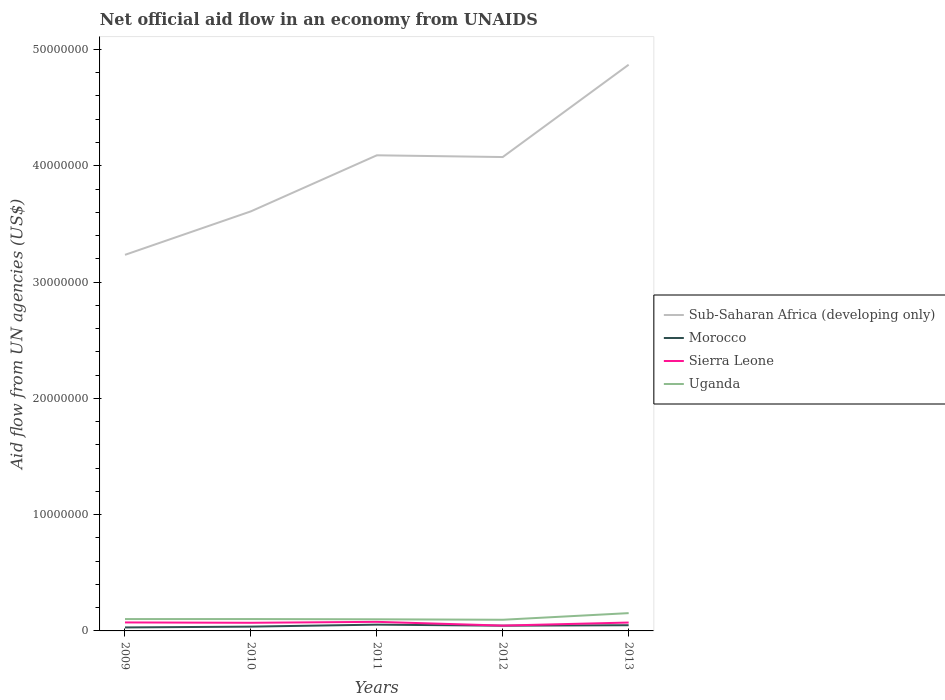How many different coloured lines are there?
Offer a very short reply. 4. Does the line corresponding to Uganda intersect with the line corresponding to Morocco?
Your answer should be very brief. No. Across all years, what is the maximum net official aid flow in Morocco?
Your answer should be very brief. 3.00e+05. What is the total net official aid flow in Morocco in the graph?
Give a very brief answer. -1.70e+05. What is the difference between the highest and the second highest net official aid flow in Uganda?
Keep it short and to the point. 5.70e+05. What is the difference between the highest and the lowest net official aid flow in Uganda?
Make the answer very short. 1. How many lines are there?
Your answer should be very brief. 4. What is the difference between two consecutive major ticks on the Y-axis?
Offer a terse response. 1.00e+07. Are the values on the major ticks of Y-axis written in scientific E-notation?
Make the answer very short. No. Does the graph contain any zero values?
Ensure brevity in your answer.  No. Where does the legend appear in the graph?
Make the answer very short. Center right. How many legend labels are there?
Ensure brevity in your answer.  4. How are the legend labels stacked?
Provide a short and direct response. Vertical. What is the title of the graph?
Make the answer very short. Net official aid flow in an economy from UNAIDS. Does "Trinidad and Tobago" appear as one of the legend labels in the graph?
Ensure brevity in your answer.  No. What is the label or title of the X-axis?
Give a very brief answer. Years. What is the label or title of the Y-axis?
Your response must be concise. Aid flow from UN agencies (US$). What is the Aid flow from UN agencies (US$) of Sub-Saharan Africa (developing only) in 2009?
Provide a short and direct response. 3.23e+07. What is the Aid flow from UN agencies (US$) in Sierra Leone in 2009?
Your response must be concise. 7.30e+05. What is the Aid flow from UN agencies (US$) in Uganda in 2009?
Provide a short and direct response. 1.02e+06. What is the Aid flow from UN agencies (US$) in Sub-Saharan Africa (developing only) in 2010?
Your answer should be compact. 3.61e+07. What is the Aid flow from UN agencies (US$) in Sierra Leone in 2010?
Make the answer very short. 7.00e+05. What is the Aid flow from UN agencies (US$) of Uganda in 2010?
Provide a short and direct response. 1.02e+06. What is the Aid flow from UN agencies (US$) in Sub-Saharan Africa (developing only) in 2011?
Provide a succinct answer. 4.09e+07. What is the Aid flow from UN agencies (US$) in Morocco in 2011?
Your answer should be compact. 5.40e+05. What is the Aid flow from UN agencies (US$) of Sierra Leone in 2011?
Provide a short and direct response. 7.80e+05. What is the Aid flow from UN agencies (US$) in Sub-Saharan Africa (developing only) in 2012?
Provide a succinct answer. 4.08e+07. What is the Aid flow from UN agencies (US$) of Morocco in 2012?
Your answer should be very brief. 4.50e+05. What is the Aid flow from UN agencies (US$) in Uganda in 2012?
Keep it short and to the point. 9.60e+05. What is the Aid flow from UN agencies (US$) in Sub-Saharan Africa (developing only) in 2013?
Ensure brevity in your answer.  4.87e+07. What is the Aid flow from UN agencies (US$) of Sierra Leone in 2013?
Provide a short and direct response. 7.20e+05. What is the Aid flow from UN agencies (US$) in Uganda in 2013?
Your answer should be very brief. 1.53e+06. Across all years, what is the maximum Aid flow from UN agencies (US$) in Sub-Saharan Africa (developing only)?
Make the answer very short. 4.87e+07. Across all years, what is the maximum Aid flow from UN agencies (US$) in Morocco?
Keep it short and to the point. 5.40e+05. Across all years, what is the maximum Aid flow from UN agencies (US$) in Sierra Leone?
Make the answer very short. 7.80e+05. Across all years, what is the maximum Aid flow from UN agencies (US$) in Uganda?
Offer a very short reply. 1.53e+06. Across all years, what is the minimum Aid flow from UN agencies (US$) in Sub-Saharan Africa (developing only)?
Keep it short and to the point. 3.23e+07. Across all years, what is the minimum Aid flow from UN agencies (US$) of Morocco?
Your response must be concise. 3.00e+05. Across all years, what is the minimum Aid flow from UN agencies (US$) of Uganda?
Ensure brevity in your answer.  9.60e+05. What is the total Aid flow from UN agencies (US$) of Sub-Saharan Africa (developing only) in the graph?
Keep it short and to the point. 1.99e+08. What is the total Aid flow from UN agencies (US$) in Morocco in the graph?
Offer a terse response. 2.15e+06. What is the total Aid flow from UN agencies (US$) in Sierra Leone in the graph?
Keep it short and to the point. 3.39e+06. What is the total Aid flow from UN agencies (US$) of Uganda in the graph?
Your response must be concise. 5.53e+06. What is the difference between the Aid flow from UN agencies (US$) in Sub-Saharan Africa (developing only) in 2009 and that in 2010?
Make the answer very short. -3.74e+06. What is the difference between the Aid flow from UN agencies (US$) of Sub-Saharan Africa (developing only) in 2009 and that in 2011?
Your answer should be very brief. -8.56e+06. What is the difference between the Aid flow from UN agencies (US$) of Morocco in 2009 and that in 2011?
Keep it short and to the point. -2.40e+05. What is the difference between the Aid flow from UN agencies (US$) in Sierra Leone in 2009 and that in 2011?
Make the answer very short. -5.00e+04. What is the difference between the Aid flow from UN agencies (US$) in Sub-Saharan Africa (developing only) in 2009 and that in 2012?
Offer a terse response. -8.41e+06. What is the difference between the Aid flow from UN agencies (US$) in Sierra Leone in 2009 and that in 2012?
Offer a very short reply. 2.70e+05. What is the difference between the Aid flow from UN agencies (US$) in Uganda in 2009 and that in 2012?
Ensure brevity in your answer.  6.00e+04. What is the difference between the Aid flow from UN agencies (US$) in Sub-Saharan Africa (developing only) in 2009 and that in 2013?
Offer a terse response. -1.64e+07. What is the difference between the Aid flow from UN agencies (US$) in Morocco in 2009 and that in 2013?
Keep it short and to the point. -1.90e+05. What is the difference between the Aid flow from UN agencies (US$) in Uganda in 2009 and that in 2013?
Make the answer very short. -5.10e+05. What is the difference between the Aid flow from UN agencies (US$) in Sub-Saharan Africa (developing only) in 2010 and that in 2011?
Your answer should be compact. -4.82e+06. What is the difference between the Aid flow from UN agencies (US$) in Morocco in 2010 and that in 2011?
Give a very brief answer. -1.70e+05. What is the difference between the Aid flow from UN agencies (US$) in Sierra Leone in 2010 and that in 2011?
Your response must be concise. -8.00e+04. What is the difference between the Aid flow from UN agencies (US$) of Sub-Saharan Africa (developing only) in 2010 and that in 2012?
Ensure brevity in your answer.  -4.67e+06. What is the difference between the Aid flow from UN agencies (US$) of Sierra Leone in 2010 and that in 2012?
Offer a terse response. 2.40e+05. What is the difference between the Aid flow from UN agencies (US$) of Uganda in 2010 and that in 2012?
Make the answer very short. 6.00e+04. What is the difference between the Aid flow from UN agencies (US$) in Sub-Saharan Africa (developing only) in 2010 and that in 2013?
Offer a terse response. -1.26e+07. What is the difference between the Aid flow from UN agencies (US$) in Morocco in 2010 and that in 2013?
Provide a succinct answer. -1.20e+05. What is the difference between the Aid flow from UN agencies (US$) of Uganda in 2010 and that in 2013?
Offer a terse response. -5.10e+05. What is the difference between the Aid flow from UN agencies (US$) of Sub-Saharan Africa (developing only) in 2011 and that in 2012?
Provide a short and direct response. 1.50e+05. What is the difference between the Aid flow from UN agencies (US$) of Sub-Saharan Africa (developing only) in 2011 and that in 2013?
Give a very brief answer. -7.79e+06. What is the difference between the Aid flow from UN agencies (US$) of Sierra Leone in 2011 and that in 2013?
Keep it short and to the point. 6.00e+04. What is the difference between the Aid flow from UN agencies (US$) of Uganda in 2011 and that in 2013?
Provide a succinct answer. -5.30e+05. What is the difference between the Aid flow from UN agencies (US$) of Sub-Saharan Africa (developing only) in 2012 and that in 2013?
Give a very brief answer. -7.94e+06. What is the difference between the Aid flow from UN agencies (US$) in Morocco in 2012 and that in 2013?
Provide a short and direct response. -4.00e+04. What is the difference between the Aid flow from UN agencies (US$) in Sierra Leone in 2012 and that in 2013?
Your answer should be very brief. -2.60e+05. What is the difference between the Aid flow from UN agencies (US$) in Uganda in 2012 and that in 2013?
Provide a succinct answer. -5.70e+05. What is the difference between the Aid flow from UN agencies (US$) of Sub-Saharan Africa (developing only) in 2009 and the Aid flow from UN agencies (US$) of Morocco in 2010?
Your response must be concise. 3.20e+07. What is the difference between the Aid flow from UN agencies (US$) in Sub-Saharan Africa (developing only) in 2009 and the Aid flow from UN agencies (US$) in Sierra Leone in 2010?
Provide a succinct answer. 3.16e+07. What is the difference between the Aid flow from UN agencies (US$) in Sub-Saharan Africa (developing only) in 2009 and the Aid flow from UN agencies (US$) in Uganda in 2010?
Offer a terse response. 3.13e+07. What is the difference between the Aid flow from UN agencies (US$) of Morocco in 2009 and the Aid flow from UN agencies (US$) of Sierra Leone in 2010?
Offer a very short reply. -4.00e+05. What is the difference between the Aid flow from UN agencies (US$) in Morocco in 2009 and the Aid flow from UN agencies (US$) in Uganda in 2010?
Make the answer very short. -7.20e+05. What is the difference between the Aid flow from UN agencies (US$) in Sub-Saharan Africa (developing only) in 2009 and the Aid flow from UN agencies (US$) in Morocco in 2011?
Your response must be concise. 3.18e+07. What is the difference between the Aid flow from UN agencies (US$) of Sub-Saharan Africa (developing only) in 2009 and the Aid flow from UN agencies (US$) of Sierra Leone in 2011?
Provide a succinct answer. 3.16e+07. What is the difference between the Aid flow from UN agencies (US$) of Sub-Saharan Africa (developing only) in 2009 and the Aid flow from UN agencies (US$) of Uganda in 2011?
Keep it short and to the point. 3.13e+07. What is the difference between the Aid flow from UN agencies (US$) in Morocco in 2009 and the Aid flow from UN agencies (US$) in Sierra Leone in 2011?
Ensure brevity in your answer.  -4.80e+05. What is the difference between the Aid flow from UN agencies (US$) of Morocco in 2009 and the Aid flow from UN agencies (US$) of Uganda in 2011?
Your response must be concise. -7.00e+05. What is the difference between the Aid flow from UN agencies (US$) of Sierra Leone in 2009 and the Aid flow from UN agencies (US$) of Uganda in 2011?
Keep it short and to the point. -2.70e+05. What is the difference between the Aid flow from UN agencies (US$) of Sub-Saharan Africa (developing only) in 2009 and the Aid flow from UN agencies (US$) of Morocco in 2012?
Give a very brief answer. 3.19e+07. What is the difference between the Aid flow from UN agencies (US$) of Sub-Saharan Africa (developing only) in 2009 and the Aid flow from UN agencies (US$) of Sierra Leone in 2012?
Your answer should be compact. 3.19e+07. What is the difference between the Aid flow from UN agencies (US$) of Sub-Saharan Africa (developing only) in 2009 and the Aid flow from UN agencies (US$) of Uganda in 2012?
Ensure brevity in your answer.  3.14e+07. What is the difference between the Aid flow from UN agencies (US$) of Morocco in 2009 and the Aid flow from UN agencies (US$) of Uganda in 2012?
Keep it short and to the point. -6.60e+05. What is the difference between the Aid flow from UN agencies (US$) of Sub-Saharan Africa (developing only) in 2009 and the Aid flow from UN agencies (US$) of Morocco in 2013?
Your response must be concise. 3.18e+07. What is the difference between the Aid flow from UN agencies (US$) of Sub-Saharan Africa (developing only) in 2009 and the Aid flow from UN agencies (US$) of Sierra Leone in 2013?
Provide a short and direct response. 3.16e+07. What is the difference between the Aid flow from UN agencies (US$) in Sub-Saharan Africa (developing only) in 2009 and the Aid flow from UN agencies (US$) in Uganda in 2013?
Keep it short and to the point. 3.08e+07. What is the difference between the Aid flow from UN agencies (US$) of Morocco in 2009 and the Aid flow from UN agencies (US$) of Sierra Leone in 2013?
Ensure brevity in your answer.  -4.20e+05. What is the difference between the Aid flow from UN agencies (US$) in Morocco in 2009 and the Aid flow from UN agencies (US$) in Uganda in 2013?
Provide a succinct answer. -1.23e+06. What is the difference between the Aid flow from UN agencies (US$) of Sierra Leone in 2009 and the Aid flow from UN agencies (US$) of Uganda in 2013?
Ensure brevity in your answer.  -8.00e+05. What is the difference between the Aid flow from UN agencies (US$) of Sub-Saharan Africa (developing only) in 2010 and the Aid flow from UN agencies (US$) of Morocco in 2011?
Your answer should be very brief. 3.55e+07. What is the difference between the Aid flow from UN agencies (US$) in Sub-Saharan Africa (developing only) in 2010 and the Aid flow from UN agencies (US$) in Sierra Leone in 2011?
Your answer should be very brief. 3.53e+07. What is the difference between the Aid flow from UN agencies (US$) in Sub-Saharan Africa (developing only) in 2010 and the Aid flow from UN agencies (US$) in Uganda in 2011?
Your response must be concise. 3.51e+07. What is the difference between the Aid flow from UN agencies (US$) in Morocco in 2010 and the Aid flow from UN agencies (US$) in Sierra Leone in 2011?
Your response must be concise. -4.10e+05. What is the difference between the Aid flow from UN agencies (US$) in Morocco in 2010 and the Aid flow from UN agencies (US$) in Uganda in 2011?
Your answer should be very brief. -6.30e+05. What is the difference between the Aid flow from UN agencies (US$) in Sierra Leone in 2010 and the Aid flow from UN agencies (US$) in Uganda in 2011?
Offer a very short reply. -3.00e+05. What is the difference between the Aid flow from UN agencies (US$) of Sub-Saharan Africa (developing only) in 2010 and the Aid flow from UN agencies (US$) of Morocco in 2012?
Your response must be concise. 3.56e+07. What is the difference between the Aid flow from UN agencies (US$) of Sub-Saharan Africa (developing only) in 2010 and the Aid flow from UN agencies (US$) of Sierra Leone in 2012?
Ensure brevity in your answer.  3.56e+07. What is the difference between the Aid flow from UN agencies (US$) in Sub-Saharan Africa (developing only) in 2010 and the Aid flow from UN agencies (US$) in Uganda in 2012?
Make the answer very short. 3.51e+07. What is the difference between the Aid flow from UN agencies (US$) of Morocco in 2010 and the Aid flow from UN agencies (US$) of Uganda in 2012?
Offer a terse response. -5.90e+05. What is the difference between the Aid flow from UN agencies (US$) in Sub-Saharan Africa (developing only) in 2010 and the Aid flow from UN agencies (US$) in Morocco in 2013?
Give a very brief answer. 3.56e+07. What is the difference between the Aid flow from UN agencies (US$) in Sub-Saharan Africa (developing only) in 2010 and the Aid flow from UN agencies (US$) in Sierra Leone in 2013?
Offer a terse response. 3.54e+07. What is the difference between the Aid flow from UN agencies (US$) in Sub-Saharan Africa (developing only) in 2010 and the Aid flow from UN agencies (US$) in Uganda in 2013?
Your response must be concise. 3.46e+07. What is the difference between the Aid flow from UN agencies (US$) in Morocco in 2010 and the Aid flow from UN agencies (US$) in Sierra Leone in 2013?
Ensure brevity in your answer.  -3.50e+05. What is the difference between the Aid flow from UN agencies (US$) of Morocco in 2010 and the Aid flow from UN agencies (US$) of Uganda in 2013?
Offer a very short reply. -1.16e+06. What is the difference between the Aid flow from UN agencies (US$) in Sierra Leone in 2010 and the Aid flow from UN agencies (US$) in Uganda in 2013?
Keep it short and to the point. -8.30e+05. What is the difference between the Aid flow from UN agencies (US$) of Sub-Saharan Africa (developing only) in 2011 and the Aid flow from UN agencies (US$) of Morocco in 2012?
Offer a terse response. 4.04e+07. What is the difference between the Aid flow from UN agencies (US$) of Sub-Saharan Africa (developing only) in 2011 and the Aid flow from UN agencies (US$) of Sierra Leone in 2012?
Provide a succinct answer. 4.04e+07. What is the difference between the Aid flow from UN agencies (US$) in Sub-Saharan Africa (developing only) in 2011 and the Aid flow from UN agencies (US$) in Uganda in 2012?
Ensure brevity in your answer.  3.99e+07. What is the difference between the Aid flow from UN agencies (US$) in Morocco in 2011 and the Aid flow from UN agencies (US$) in Uganda in 2012?
Make the answer very short. -4.20e+05. What is the difference between the Aid flow from UN agencies (US$) of Sub-Saharan Africa (developing only) in 2011 and the Aid flow from UN agencies (US$) of Morocco in 2013?
Provide a succinct answer. 4.04e+07. What is the difference between the Aid flow from UN agencies (US$) in Sub-Saharan Africa (developing only) in 2011 and the Aid flow from UN agencies (US$) in Sierra Leone in 2013?
Give a very brief answer. 4.02e+07. What is the difference between the Aid flow from UN agencies (US$) in Sub-Saharan Africa (developing only) in 2011 and the Aid flow from UN agencies (US$) in Uganda in 2013?
Make the answer very short. 3.94e+07. What is the difference between the Aid flow from UN agencies (US$) in Morocco in 2011 and the Aid flow from UN agencies (US$) in Uganda in 2013?
Your answer should be compact. -9.90e+05. What is the difference between the Aid flow from UN agencies (US$) in Sierra Leone in 2011 and the Aid flow from UN agencies (US$) in Uganda in 2013?
Keep it short and to the point. -7.50e+05. What is the difference between the Aid flow from UN agencies (US$) of Sub-Saharan Africa (developing only) in 2012 and the Aid flow from UN agencies (US$) of Morocco in 2013?
Offer a very short reply. 4.03e+07. What is the difference between the Aid flow from UN agencies (US$) of Sub-Saharan Africa (developing only) in 2012 and the Aid flow from UN agencies (US$) of Sierra Leone in 2013?
Your answer should be compact. 4.00e+07. What is the difference between the Aid flow from UN agencies (US$) in Sub-Saharan Africa (developing only) in 2012 and the Aid flow from UN agencies (US$) in Uganda in 2013?
Ensure brevity in your answer.  3.92e+07. What is the difference between the Aid flow from UN agencies (US$) of Morocco in 2012 and the Aid flow from UN agencies (US$) of Sierra Leone in 2013?
Give a very brief answer. -2.70e+05. What is the difference between the Aid flow from UN agencies (US$) in Morocco in 2012 and the Aid flow from UN agencies (US$) in Uganda in 2013?
Your answer should be compact. -1.08e+06. What is the difference between the Aid flow from UN agencies (US$) of Sierra Leone in 2012 and the Aid flow from UN agencies (US$) of Uganda in 2013?
Keep it short and to the point. -1.07e+06. What is the average Aid flow from UN agencies (US$) in Sub-Saharan Africa (developing only) per year?
Keep it short and to the point. 3.98e+07. What is the average Aid flow from UN agencies (US$) of Sierra Leone per year?
Provide a short and direct response. 6.78e+05. What is the average Aid flow from UN agencies (US$) in Uganda per year?
Offer a terse response. 1.11e+06. In the year 2009, what is the difference between the Aid flow from UN agencies (US$) of Sub-Saharan Africa (developing only) and Aid flow from UN agencies (US$) of Morocco?
Provide a short and direct response. 3.20e+07. In the year 2009, what is the difference between the Aid flow from UN agencies (US$) in Sub-Saharan Africa (developing only) and Aid flow from UN agencies (US$) in Sierra Leone?
Make the answer very short. 3.16e+07. In the year 2009, what is the difference between the Aid flow from UN agencies (US$) of Sub-Saharan Africa (developing only) and Aid flow from UN agencies (US$) of Uganda?
Your answer should be very brief. 3.13e+07. In the year 2009, what is the difference between the Aid flow from UN agencies (US$) of Morocco and Aid flow from UN agencies (US$) of Sierra Leone?
Your answer should be very brief. -4.30e+05. In the year 2009, what is the difference between the Aid flow from UN agencies (US$) in Morocco and Aid flow from UN agencies (US$) in Uganda?
Keep it short and to the point. -7.20e+05. In the year 2010, what is the difference between the Aid flow from UN agencies (US$) of Sub-Saharan Africa (developing only) and Aid flow from UN agencies (US$) of Morocco?
Offer a terse response. 3.57e+07. In the year 2010, what is the difference between the Aid flow from UN agencies (US$) of Sub-Saharan Africa (developing only) and Aid flow from UN agencies (US$) of Sierra Leone?
Keep it short and to the point. 3.54e+07. In the year 2010, what is the difference between the Aid flow from UN agencies (US$) of Sub-Saharan Africa (developing only) and Aid flow from UN agencies (US$) of Uganda?
Keep it short and to the point. 3.51e+07. In the year 2010, what is the difference between the Aid flow from UN agencies (US$) in Morocco and Aid flow from UN agencies (US$) in Sierra Leone?
Your answer should be very brief. -3.30e+05. In the year 2010, what is the difference between the Aid flow from UN agencies (US$) in Morocco and Aid flow from UN agencies (US$) in Uganda?
Your answer should be very brief. -6.50e+05. In the year 2010, what is the difference between the Aid flow from UN agencies (US$) of Sierra Leone and Aid flow from UN agencies (US$) of Uganda?
Your answer should be very brief. -3.20e+05. In the year 2011, what is the difference between the Aid flow from UN agencies (US$) of Sub-Saharan Africa (developing only) and Aid flow from UN agencies (US$) of Morocco?
Provide a succinct answer. 4.04e+07. In the year 2011, what is the difference between the Aid flow from UN agencies (US$) in Sub-Saharan Africa (developing only) and Aid flow from UN agencies (US$) in Sierra Leone?
Ensure brevity in your answer.  4.01e+07. In the year 2011, what is the difference between the Aid flow from UN agencies (US$) of Sub-Saharan Africa (developing only) and Aid flow from UN agencies (US$) of Uganda?
Offer a terse response. 3.99e+07. In the year 2011, what is the difference between the Aid flow from UN agencies (US$) of Morocco and Aid flow from UN agencies (US$) of Uganda?
Offer a very short reply. -4.60e+05. In the year 2011, what is the difference between the Aid flow from UN agencies (US$) of Sierra Leone and Aid flow from UN agencies (US$) of Uganda?
Your answer should be compact. -2.20e+05. In the year 2012, what is the difference between the Aid flow from UN agencies (US$) in Sub-Saharan Africa (developing only) and Aid flow from UN agencies (US$) in Morocco?
Your answer should be compact. 4.03e+07. In the year 2012, what is the difference between the Aid flow from UN agencies (US$) of Sub-Saharan Africa (developing only) and Aid flow from UN agencies (US$) of Sierra Leone?
Provide a short and direct response. 4.03e+07. In the year 2012, what is the difference between the Aid flow from UN agencies (US$) in Sub-Saharan Africa (developing only) and Aid flow from UN agencies (US$) in Uganda?
Offer a very short reply. 3.98e+07. In the year 2012, what is the difference between the Aid flow from UN agencies (US$) in Morocco and Aid flow from UN agencies (US$) in Uganda?
Make the answer very short. -5.10e+05. In the year 2012, what is the difference between the Aid flow from UN agencies (US$) of Sierra Leone and Aid flow from UN agencies (US$) of Uganda?
Your response must be concise. -5.00e+05. In the year 2013, what is the difference between the Aid flow from UN agencies (US$) of Sub-Saharan Africa (developing only) and Aid flow from UN agencies (US$) of Morocco?
Offer a very short reply. 4.82e+07. In the year 2013, what is the difference between the Aid flow from UN agencies (US$) in Sub-Saharan Africa (developing only) and Aid flow from UN agencies (US$) in Sierra Leone?
Your answer should be very brief. 4.80e+07. In the year 2013, what is the difference between the Aid flow from UN agencies (US$) of Sub-Saharan Africa (developing only) and Aid flow from UN agencies (US$) of Uganda?
Keep it short and to the point. 4.72e+07. In the year 2013, what is the difference between the Aid flow from UN agencies (US$) of Morocco and Aid flow from UN agencies (US$) of Uganda?
Ensure brevity in your answer.  -1.04e+06. In the year 2013, what is the difference between the Aid flow from UN agencies (US$) in Sierra Leone and Aid flow from UN agencies (US$) in Uganda?
Your answer should be compact. -8.10e+05. What is the ratio of the Aid flow from UN agencies (US$) in Sub-Saharan Africa (developing only) in 2009 to that in 2010?
Your response must be concise. 0.9. What is the ratio of the Aid flow from UN agencies (US$) in Morocco in 2009 to that in 2010?
Offer a very short reply. 0.81. What is the ratio of the Aid flow from UN agencies (US$) of Sierra Leone in 2009 to that in 2010?
Keep it short and to the point. 1.04. What is the ratio of the Aid flow from UN agencies (US$) in Uganda in 2009 to that in 2010?
Ensure brevity in your answer.  1. What is the ratio of the Aid flow from UN agencies (US$) in Sub-Saharan Africa (developing only) in 2009 to that in 2011?
Make the answer very short. 0.79. What is the ratio of the Aid flow from UN agencies (US$) of Morocco in 2009 to that in 2011?
Offer a terse response. 0.56. What is the ratio of the Aid flow from UN agencies (US$) of Sierra Leone in 2009 to that in 2011?
Make the answer very short. 0.94. What is the ratio of the Aid flow from UN agencies (US$) in Uganda in 2009 to that in 2011?
Provide a succinct answer. 1.02. What is the ratio of the Aid flow from UN agencies (US$) of Sub-Saharan Africa (developing only) in 2009 to that in 2012?
Provide a succinct answer. 0.79. What is the ratio of the Aid flow from UN agencies (US$) of Morocco in 2009 to that in 2012?
Provide a succinct answer. 0.67. What is the ratio of the Aid flow from UN agencies (US$) in Sierra Leone in 2009 to that in 2012?
Offer a terse response. 1.59. What is the ratio of the Aid flow from UN agencies (US$) in Sub-Saharan Africa (developing only) in 2009 to that in 2013?
Your answer should be very brief. 0.66. What is the ratio of the Aid flow from UN agencies (US$) in Morocco in 2009 to that in 2013?
Ensure brevity in your answer.  0.61. What is the ratio of the Aid flow from UN agencies (US$) in Sierra Leone in 2009 to that in 2013?
Your answer should be compact. 1.01. What is the ratio of the Aid flow from UN agencies (US$) in Uganda in 2009 to that in 2013?
Give a very brief answer. 0.67. What is the ratio of the Aid flow from UN agencies (US$) of Sub-Saharan Africa (developing only) in 2010 to that in 2011?
Keep it short and to the point. 0.88. What is the ratio of the Aid flow from UN agencies (US$) of Morocco in 2010 to that in 2011?
Keep it short and to the point. 0.69. What is the ratio of the Aid flow from UN agencies (US$) of Sierra Leone in 2010 to that in 2011?
Offer a very short reply. 0.9. What is the ratio of the Aid flow from UN agencies (US$) of Sub-Saharan Africa (developing only) in 2010 to that in 2012?
Your answer should be very brief. 0.89. What is the ratio of the Aid flow from UN agencies (US$) of Morocco in 2010 to that in 2012?
Keep it short and to the point. 0.82. What is the ratio of the Aid flow from UN agencies (US$) in Sierra Leone in 2010 to that in 2012?
Provide a short and direct response. 1.52. What is the ratio of the Aid flow from UN agencies (US$) in Uganda in 2010 to that in 2012?
Make the answer very short. 1.06. What is the ratio of the Aid flow from UN agencies (US$) in Sub-Saharan Africa (developing only) in 2010 to that in 2013?
Offer a very short reply. 0.74. What is the ratio of the Aid flow from UN agencies (US$) of Morocco in 2010 to that in 2013?
Offer a very short reply. 0.76. What is the ratio of the Aid flow from UN agencies (US$) of Sierra Leone in 2010 to that in 2013?
Offer a terse response. 0.97. What is the ratio of the Aid flow from UN agencies (US$) of Sub-Saharan Africa (developing only) in 2011 to that in 2012?
Offer a terse response. 1. What is the ratio of the Aid flow from UN agencies (US$) of Morocco in 2011 to that in 2012?
Your response must be concise. 1.2. What is the ratio of the Aid flow from UN agencies (US$) in Sierra Leone in 2011 to that in 2012?
Give a very brief answer. 1.7. What is the ratio of the Aid flow from UN agencies (US$) of Uganda in 2011 to that in 2012?
Provide a succinct answer. 1.04. What is the ratio of the Aid flow from UN agencies (US$) in Sub-Saharan Africa (developing only) in 2011 to that in 2013?
Keep it short and to the point. 0.84. What is the ratio of the Aid flow from UN agencies (US$) in Morocco in 2011 to that in 2013?
Provide a short and direct response. 1.1. What is the ratio of the Aid flow from UN agencies (US$) of Sierra Leone in 2011 to that in 2013?
Provide a short and direct response. 1.08. What is the ratio of the Aid flow from UN agencies (US$) of Uganda in 2011 to that in 2013?
Your answer should be very brief. 0.65. What is the ratio of the Aid flow from UN agencies (US$) in Sub-Saharan Africa (developing only) in 2012 to that in 2013?
Offer a terse response. 0.84. What is the ratio of the Aid flow from UN agencies (US$) of Morocco in 2012 to that in 2013?
Give a very brief answer. 0.92. What is the ratio of the Aid flow from UN agencies (US$) in Sierra Leone in 2012 to that in 2013?
Offer a very short reply. 0.64. What is the ratio of the Aid flow from UN agencies (US$) of Uganda in 2012 to that in 2013?
Your answer should be compact. 0.63. What is the difference between the highest and the second highest Aid flow from UN agencies (US$) of Sub-Saharan Africa (developing only)?
Your answer should be very brief. 7.79e+06. What is the difference between the highest and the second highest Aid flow from UN agencies (US$) in Morocco?
Provide a short and direct response. 5.00e+04. What is the difference between the highest and the second highest Aid flow from UN agencies (US$) in Uganda?
Your answer should be very brief. 5.10e+05. What is the difference between the highest and the lowest Aid flow from UN agencies (US$) of Sub-Saharan Africa (developing only)?
Your answer should be very brief. 1.64e+07. What is the difference between the highest and the lowest Aid flow from UN agencies (US$) of Morocco?
Give a very brief answer. 2.40e+05. What is the difference between the highest and the lowest Aid flow from UN agencies (US$) of Sierra Leone?
Your answer should be very brief. 3.20e+05. What is the difference between the highest and the lowest Aid flow from UN agencies (US$) of Uganda?
Your response must be concise. 5.70e+05. 